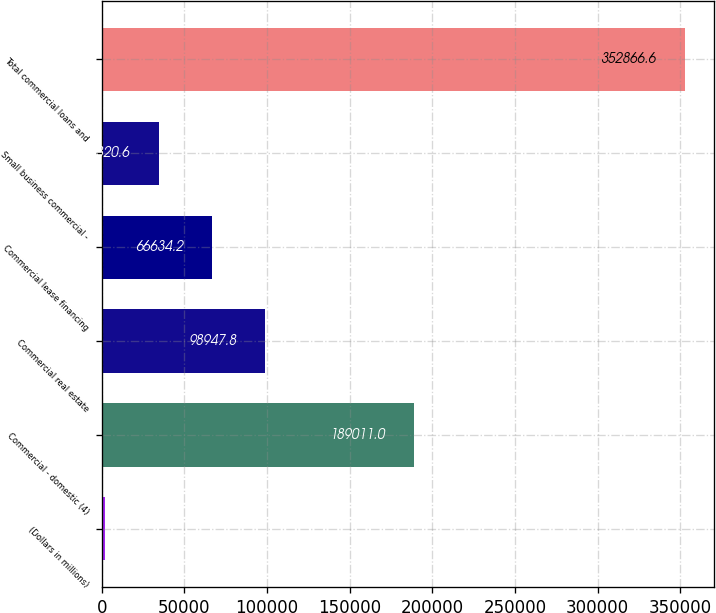Convert chart to OTSL. <chart><loc_0><loc_0><loc_500><loc_500><bar_chart><fcel>(Dollars in millions)<fcel>Commercial - domestic (4)<fcel>Commercial real estate<fcel>Commercial lease financing<fcel>Small business commercial -<fcel>Total commercial loans and<nl><fcel>2007<fcel>189011<fcel>98947.8<fcel>66634.2<fcel>34320.6<fcel>352867<nl></chart> 